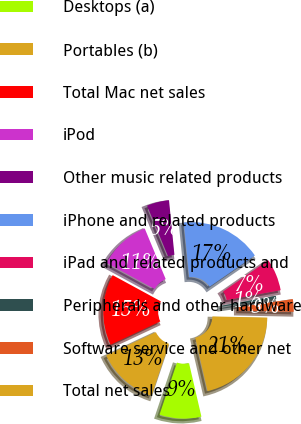Convert chart. <chart><loc_0><loc_0><loc_500><loc_500><pie_chart><fcel>Desktops (a)<fcel>Portables (b)<fcel>Total Mac net sales<fcel>iPod<fcel>Other music related products<fcel>iPhone and related products<fcel>iPad and related products and<fcel>Peripherals and other hardware<fcel>Software service and other net<fcel>Total net sales<nl><fcel>8.77%<fcel>12.87%<fcel>14.91%<fcel>10.82%<fcel>4.68%<fcel>16.96%<fcel>6.73%<fcel>0.59%<fcel>2.63%<fcel>21.05%<nl></chart> 